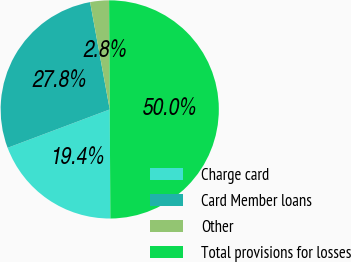Convert chart to OTSL. <chart><loc_0><loc_0><loc_500><loc_500><pie_chart><fcel>Charge card<fcel>Card Member loans<fcel>Other<fcel>Total provisions for losses<nl><fcel>19.37%<fcel>27.84%<fcel>2.79%<fcel>50.0%<nl></chart> 